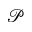<formula> <loc_0><loc_0><loc_500><loc_500>\mathcal { P }</formula> 